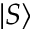Convert formula to latex. <formula><loc_0><loc_0><loc_500><loc_500>| S \rangle</formula> 